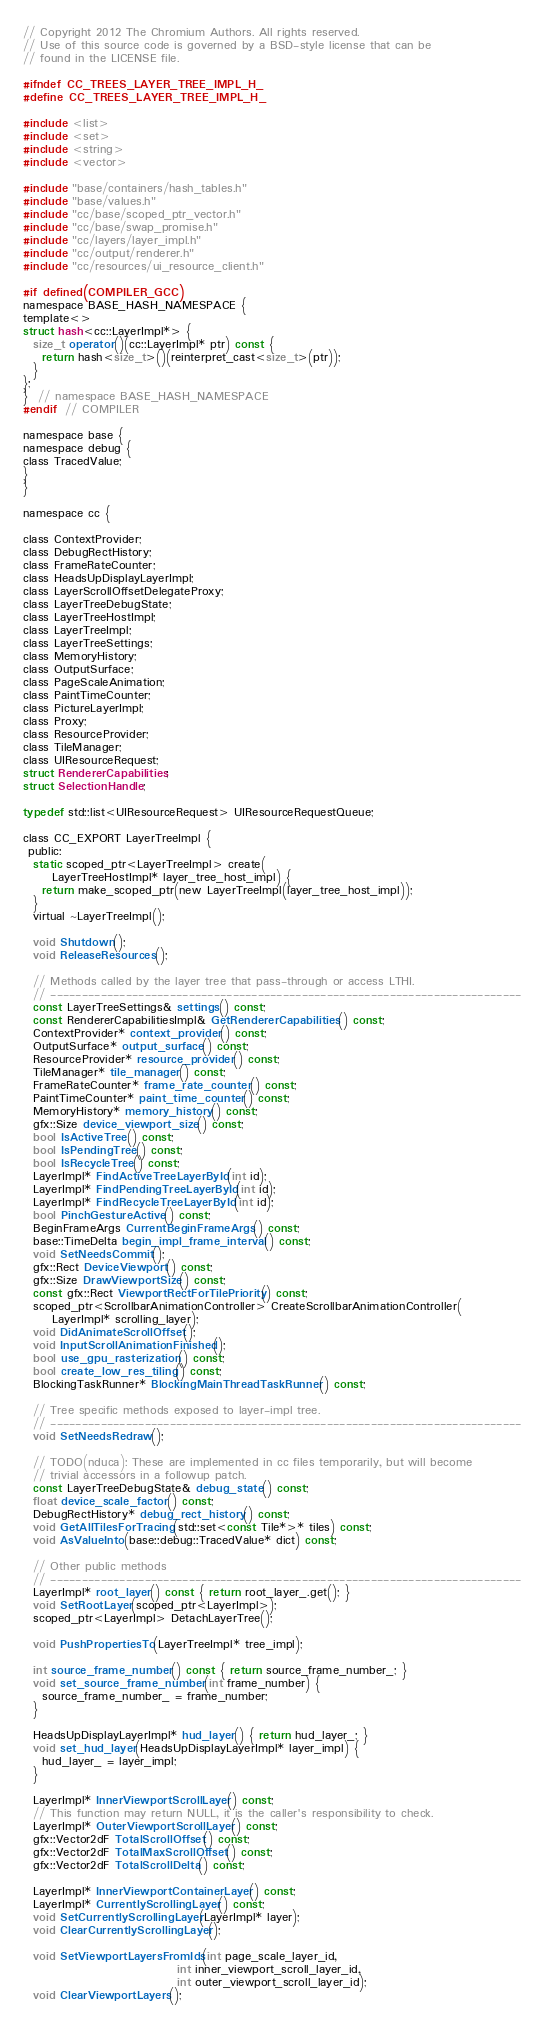<code> <loc_0><loc_0><loc_500><loc_500><_C_>// Copyright 2012 The Chromium Authors. All rights reserved.
// Use of this source code is governed by a BSD-style license that can be
// found in the LICENSE file.

#ifndef CC_TREES_LAYER_TREE_IMPL_H_
#define CC_TREES_LAYER_TREE_IMPL_H_

#include <list>
#include <set>
#include <string>
#include <vector>

#include "base/containers/hash_tables.h"
#include "base/values.h"
#include "cc/base/scoped_ptr_vector.h"
#include "cc/base/swap_promise.h"
#include "cc/layers/layer_impl.h"
#include "cc/output/renderer.h"
#include "cc/resources/ui_resource_client.h"

#if defined(COMPILER_GCC)
namespace BASE_HASH_NAMESPACE {
template<>
struct hash<cc::LayerImpl*> {
  size_t operator()(cc::LayerImpl* ptr) const {
    return hash<size_t>()(reinterpret_cast<size_t>(ptr));
  }
};
}  // namespace BASE_HASH_NAMESPACE
#endif  // COMPILER

namespace base {
namespace debug {
class TracedValue;
}
}

namespace cc {

class ContextProvider;
class DebugRectHistory;
class FrameRateCounter;
class HeadsUpDisplayLayerImpl;
class LayerScrollOffsetDelegateProxy;
class LayerTreeDebugState;
class LayerTreeHostImpl;
class LayerTreeImpl;
class LayerTreeSettings;
class MemoryHistory;
class OutputSurface;
class PageScaleAnimation;
class PaintTimeCounter;
class PictureLayerImpl;
class Proxy;
class ResourceProvider;
class TileManager;
class UIResourceRequest;
struct RendererCapabilities;
struct SelectionHandle;

typedef std::list<UIResourceRequest> UIResourceRequestQueue;

class CC_EXPORT LayerTreeImpl {
 public:
  static scoped_ptr<LayerTreeImpl> create(
      LayerTreeHostImpl* layer_tree_host_impl) {
    return make_scoped_ptr(new LayerTreeImpl(layer_tree_host_impl));
  }
  virtual ~LayerTreeImpl();

  void Shutdown();
  void ReleaseResources();

  // Methods called by the layer tree that pass-through or access LTHI.
  // ---------------------------------------------------------------------------
  const LayerTreeSettings& settings() const;
  const RendererCapabilitiesImpl& GetRendererCapabilities() const;
  ContextProvider* context_provider() const;
  OutputSurface* output_surface() const;
  ResourceProvider* resource_provider() const;
  TileManager* tile_manager() const;
  FrameRateCounter* frame_rate_counter() const;
  PaintTimeCounter* paint_time_counter() const;
  MemoryHistory* memory_history() const;
  gfx::Size device_viewport_size() const;
  bool IsActiveTree() const;
  bool IsPendingTree() const;
  bool IsRecycleTree() const;
  LayerImpl* FindActiveTreeLayerById(int id);
  LayerImpl* FindPendingTreeLayerById(int id);
  LayerImpl* FindRecycleTreeLayerById(int id);
  bool PinchGestureActive() const;
  BeginFrameArgs CurrentBeginFrameArgs() const;
  base::TimeDelta begin_impl_frame_interval() const;
  void SetNeedsCommit();
  gfx::Rect DeviceViewport() const;
  gfx::Size DrawViewportSize() const;
  const gfx::Rect ViewportRectForTilePriority() const;
  scoped_ptr<ScrollbarAnimationController> CreateScrollbarAnimationController(
      LayerImpl* scrolling_layer);
  void DidAnimateScrollOffset();
  void InputScrollAnimationFinished();
  bool use_gpu_rasterization() const;
  bool create_low_res_tiling() const;
  BlockingTaskRunner* BlockingMainThreadTaskRunner() const;

  // Tree specific methods exposed to layer-impl tree.
  // ---------------------------------------------------------------------------
  void SetNeedsRedraw();

  // TODO(nduca): These are implemented in cc files temporarily, but will become
  // trivial accessors in a followup patch.
  const LayerTreeDebugState& debug_state() const;
  float device_scale_factor() const;
  DebugRectHistory* debug_rect_history() const;
  void GetAllTilesForTracing(std::set<const Tile*>* tiles) const;
  void AsValueInto(base::debug::TracedValue* dict) const;

  // Other public methods
  // ---------------------------------------------------------------------------
  LayerImpl* root_layer() const { return root_layer_.get(); }
  void SetRootLayer(scoped_ptr<LayerImpl>);
  scoped_ptr<LayerImpl> DetachLayerTree();

  void PushPropertiesTo(LayerTreeImpl* tree_impl);

  int source_frame_number() const { return source_frame_number_; }
  void set_source_frame_number(int frame_number) {
    source_frame_number_ = frame_number;
  }

  HeadsUpDisplayLayerImpl* hud_layer() { return hud_layer_; }
  void set_hud_layer(HeadsUpDisplayLayerImpl* layer_impl) {
    hud_layer_ = layer_impl;
  }

  LayerImpl* InnerViewportScrollLayer() const;
  // This function may return NULL, it is the caller's responsibility to check.
  LayerImpl* OuterViewportScrollLayer() const;
  gfx::Vector2dF TotalScrollOffset() const;
  gfx::Vector2dF TotalMaxScrollOffset() const;
  gfx::Vector2dF TotalScrollDelta() const;

  LayerImpl* InnerViewportContainerLayer() const;
  LayerImpl* CurrentlyScrollingLayer() const;
  void SetCurrentlyScrollingLayer(LayerImpl* layer);
  void ClearCurrentlyScrollingLayer();

  void SetViewportLayersFromIds(int page_scale_layer_id,
                                int inner_viewport_scroll_layer_id,
                                int outer_viewport_scroll_layer_id);
  void ClearViewportLayers();</code> 